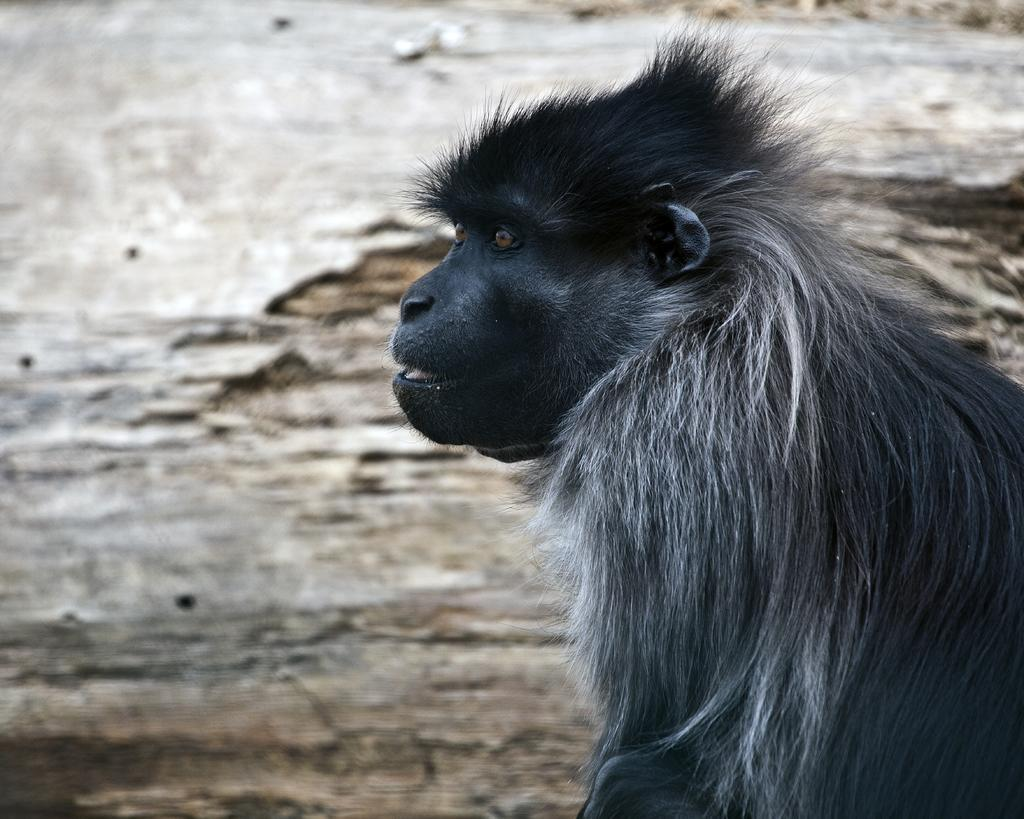What type of creature is present in the image? There is an animal in the image. Can you describe the background of the image? The background of the image is blurry. What type of brake is used to stop the animal in the image? There is no brake present in the image, as it is not a vehicle or object that requires braking. 